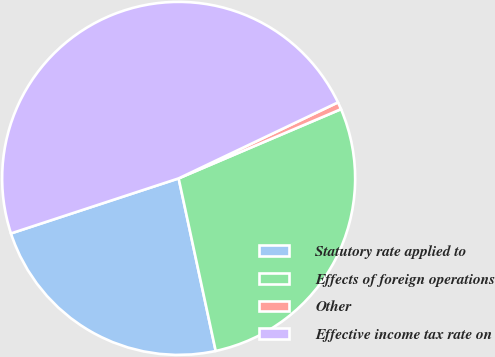Convert chart to OTSL. <chart><loc_0><loc_0><loc_500><loc_500><pie_chart><fcel>Statutory rate applied to<fcel>Effects of foreign operations<fcel>Other<fcel>Effective income tax rate on<nl><fcel>23.32%<fcel>28.05%<fcel>0.67%<fcel>47.97%<nl></chart> 